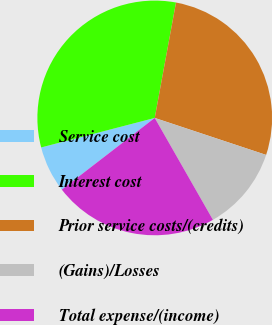Convert chart to OTSL. <chart><loc_0><loc_0><loc_500><loc_500><pie_chart><fcel>Service cost<fcel>Interest cost<fcel>Prior service costs/(credits)<fcel>(Gains)/Losses<fcel>Total expense/(income)<nl><fcel>6.41%<fcel>31.95%<fcel>27.2%<fcel>11.64%<fcel>22.8%<nl></chart> 